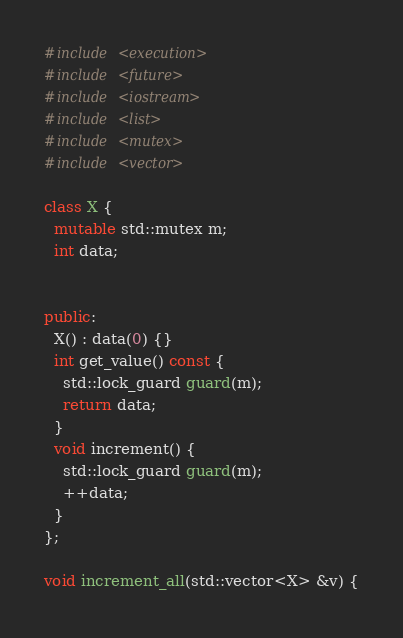Convert code to text. <code><loc_0><loc_0><loc_500><loc_500><_C++_>#include <execution>
#include <future>
#include <iostream>
#include <list>
#include <mutex>
#include <vector>

class X {
  mutable std::mutex m;
  int data;


public:
  X() : data(0) {}
  int get_value() const {
    std::lock_guard guard(m);
    return data;
  }
  void increment() {
    std::lock_guard guard(m);
    ++data;
  }
};

void increment_all(std::vector<X> &v) {
</code> 